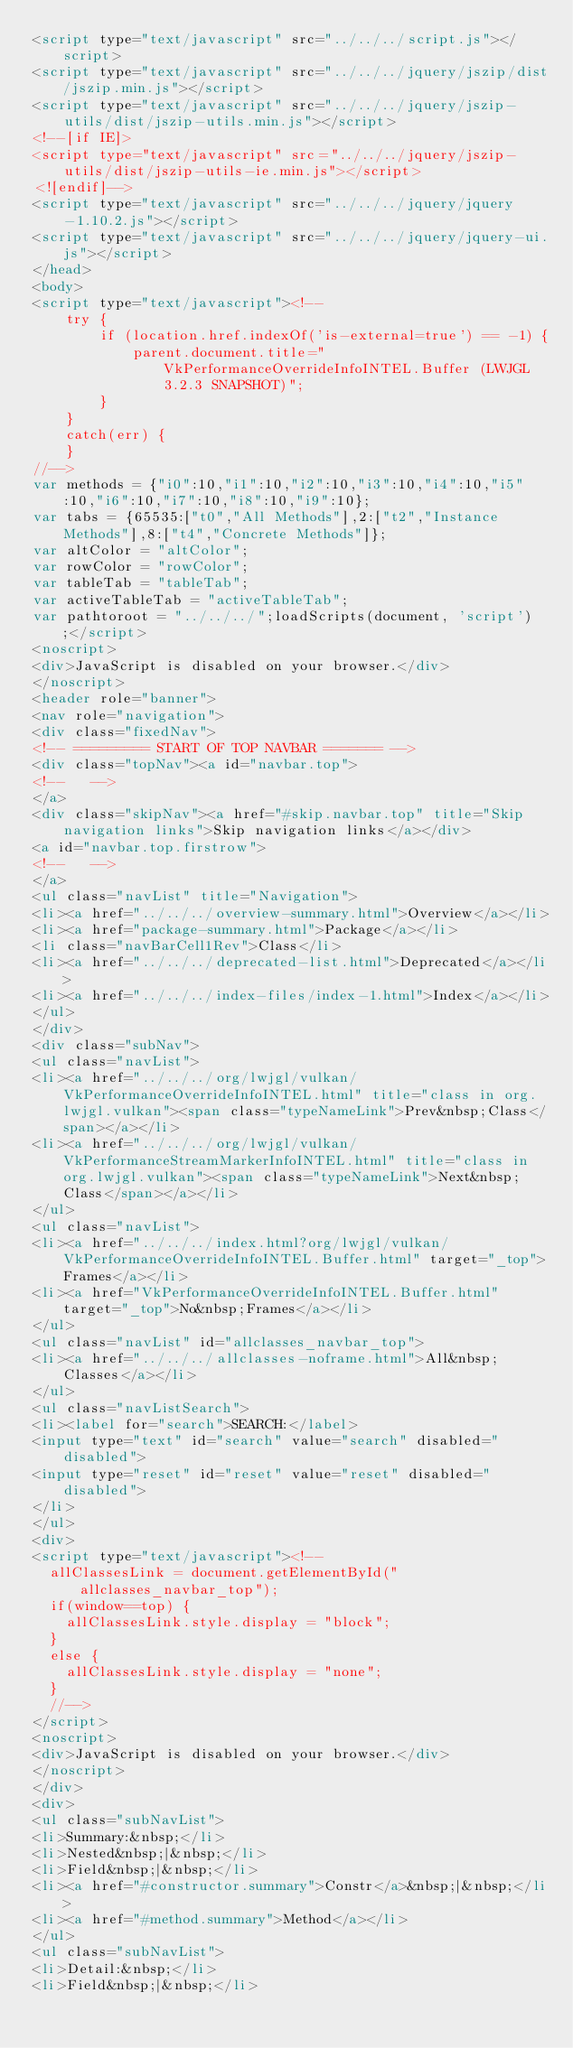<code> <loc_0><loc_0><loc_500><loc_500><_HTML_><script type="text/javascript" src="../../../script.js"></script>
<script type="text/javascript" src="../../../jquery/jszip/dist/jszip.min.js"></script>
<script type="text/javascript" src="../../../jquery/jszip-utils/dist/jszip-utils.min.js"></script>
<!--[if IE]>
<script type="text/javascript" src="../../../jquery/jszip-utils/dist/jszip-utils-ie.min.js"></script>
<![endif]-->
<script type="text/javascript" src="../../../jquery/jquery-1.10.2.js"></script>
<script type="text/javascript" src="../../../jquery/jquery-ui.js"></script>
</head>
<body>
<script type="text/javascript"><!--
    try {
        if (location.href.indexOf('is-external=true') == -1) {
            parent.document.title="VkPerformanceOverrideInfoINTEL.Buffer (LWJGL 3.2.3 SNAPSHOT)";
        }
    }
    catch(err) {
    }
//-->
var methods = {"i0":10,"i1":10,"i2":10,"i3":10,"i4":10,"i5":10,"i6":10,"i7":10,"i8":10,"i9":10};
var tabs = {65535:["t0","All Methods"],2:["t2","Instance Methods"],8:["t4","Concrete Methods"]};
var altColor = "altColor";
var rowColor = "rowColor";
var tableTab = "tableTab";
var activeTableTab = "activeTableTab";
var pathtoroot = "../../../";loadScripts(document, 'script');</script>
<noscript>
<div>JavaScript is disabled on your browser.</div>
</noscript>
<header role="banner">
<nav role="navigation">
<div class="fixedNav">
<!-- ========= START OF TOP NAVBAR ======= -->
<div class="topNav"><a id="navbar.top">
<!--   -->
</a>
<div class="skipNav"><a href="#skip.navbar.top" title="Skip navigation links">Skip navigation links</a></div>
<a id="navbar.top.firstrow">
<!--   -->
</a>
<ul class="navList" title="Navigation">
<li><a href="../../../overview-summary.html">Overview</a></li>
<li><a href="package-summary.html">Package</a></li>
<li class="navBarCell1Rev">Class</li>
<li><a href="../../../deprecated-list.html">Deprecated</a></li>
<li><a href="../../../index-files/index-1.html">Index</a></li>
</ul>
</div>
<div class="subNav">
<ul class="navList">
<li><a href="../../../org/lwjgl/vulkan/VkPerformanceOverrideInfoINTEL.html" title="class in org.lwjgl.vulkan"><span class="typeNameLink">Prev&nbsp;Class</span></a></li>
<li><a href="../../../org/lwjgl/vulkan/VkPerformanceStreamMarkerInfoINTEL.html" title="class in org.lwjgl.vulkan"><span class="typeNameLink">Next&nbsp;Class</span></a></li>
</ul>
<ul class="navList">
<li><a href="../../../index.html?org/lwjgl/vulkan/VkPerformanceOverrideInfoINTEL.Buffer.html" target="_top">Frames</a></li>
<li><a href="VkPerformanceOverrideInfoINTEL.Buffer.html" target="_top">No&nbsp;Frames</a></li>
</ul>
<ul class="navList" id="allclasses_navbar_top">
<li><a href="../../../allclasses-noframe.html">All&nbsp;Classes</a></li>
</ul>
<ul class="navListSearch">
<li><label for="search">SEARCH:</label>
<input type="text" id="search" value="search" disabled="disabled">
<input type="reset" id="reset" value="reset" disabled="disabled">
</li>
</ul>
<div>
<script type="text/javascript"><!--
  allClassesLink = document.getElementById("allclasses_navbar_top");
  if(window==top) {
    allClassesLink.style.display = "block";
  }
  else {
    allClassesLink.style.display = "none";
  }
  //-->
</script>
<noscript>
<div>JavaScript is disabled on your browser.</div>
</noscript>
</div>
<div>
<ul class="subNavList">
<li>Summary:&nbsp;</li>
<li>Nested&nbsp;|&nbsp;</li>
<li>Field&nbsp;|&nbsp;</li>
<li><a href="#constructor.summary">Constr</a>&nbsp;|&nbsp;</li>
<li><a href="#method.summary">Method</a></li>
</ul>
<ul class="subNavList">
<li>Detail:&nbsp;</li>
<li>Field&nbsp;|&nbsp;</li></code> 